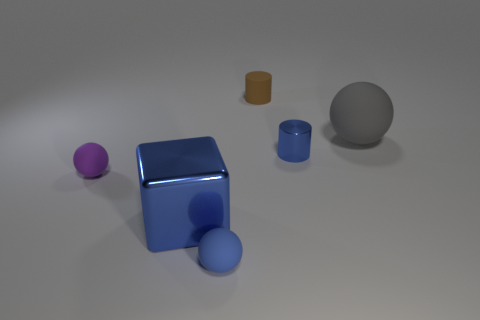Describe the lighting and shadows in the scene. The lighting in the scene comes from above, casting soft shadows below and to the right of the objects. This suggests that the light source is not directly overhead but positioned slightly to the left. The shadows are soft-edged, indicating the light source is diffused, which gives the objects a gentle, realistic appearance. 